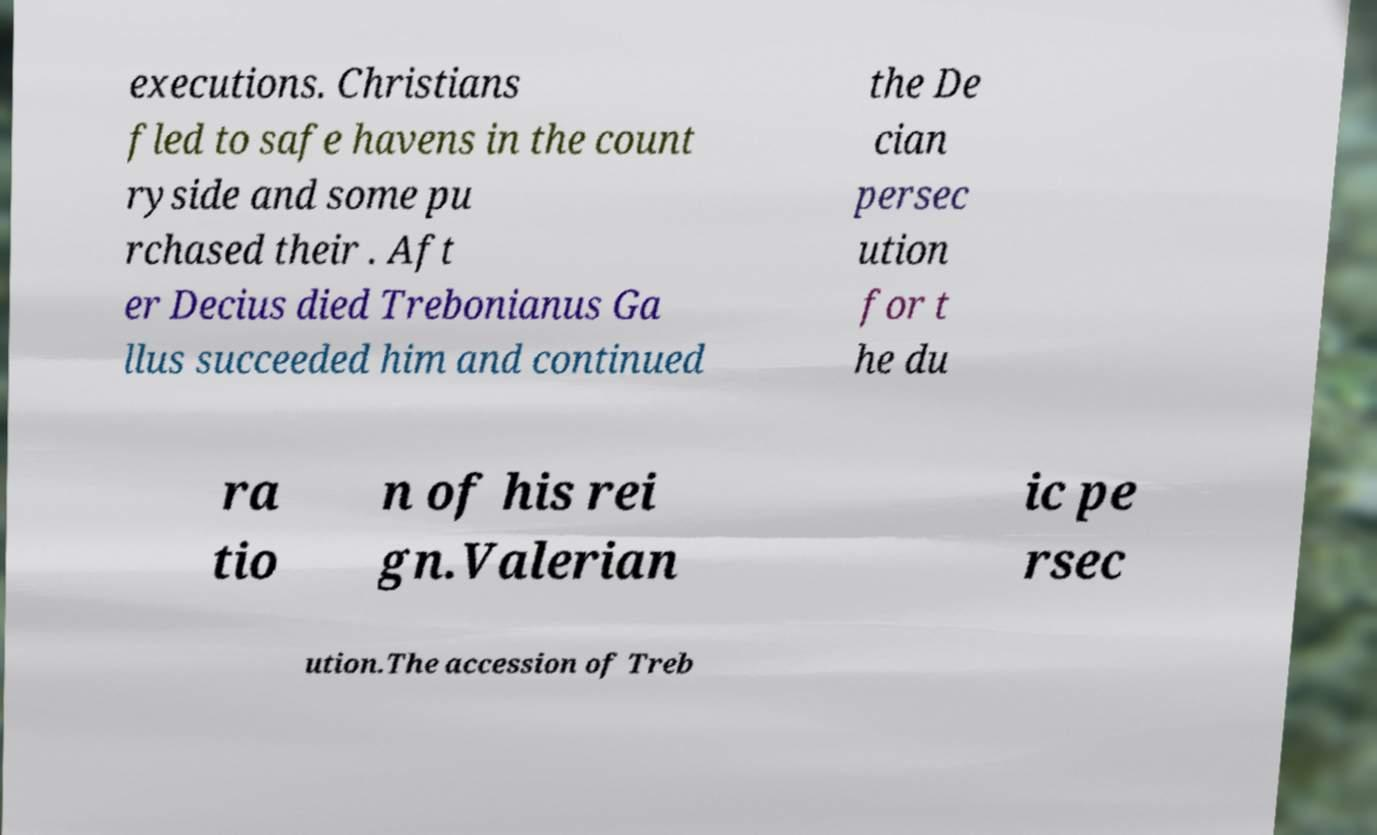There's text embedded in this image that I need extracted. Can you transcribe it verbatim? executions. Christians fled to safe havens in the count ryside and some pu rchased their . Aft er Decius died Trebonianus Ga llus succeeded him and continued the De cian persec ution for t he du ra tio n of his rei gn.Valerian ic pe rsec ution.The accession of Treb 